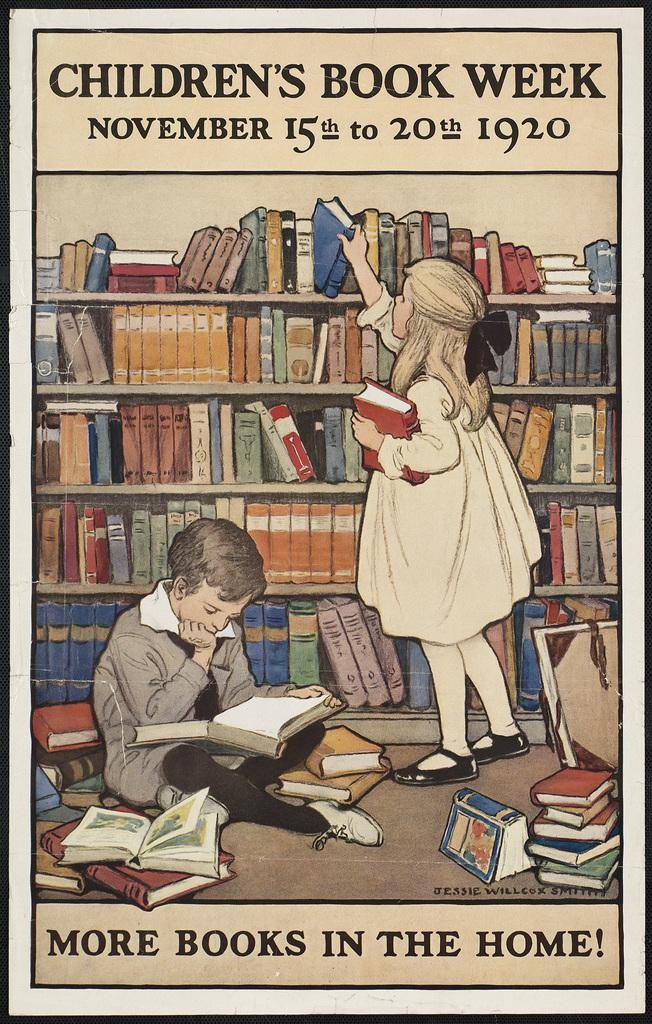<image>
Give a short and clear explanation of the subsequent image. An illustrated poster of two children in a library advertises Children's Book Week. 